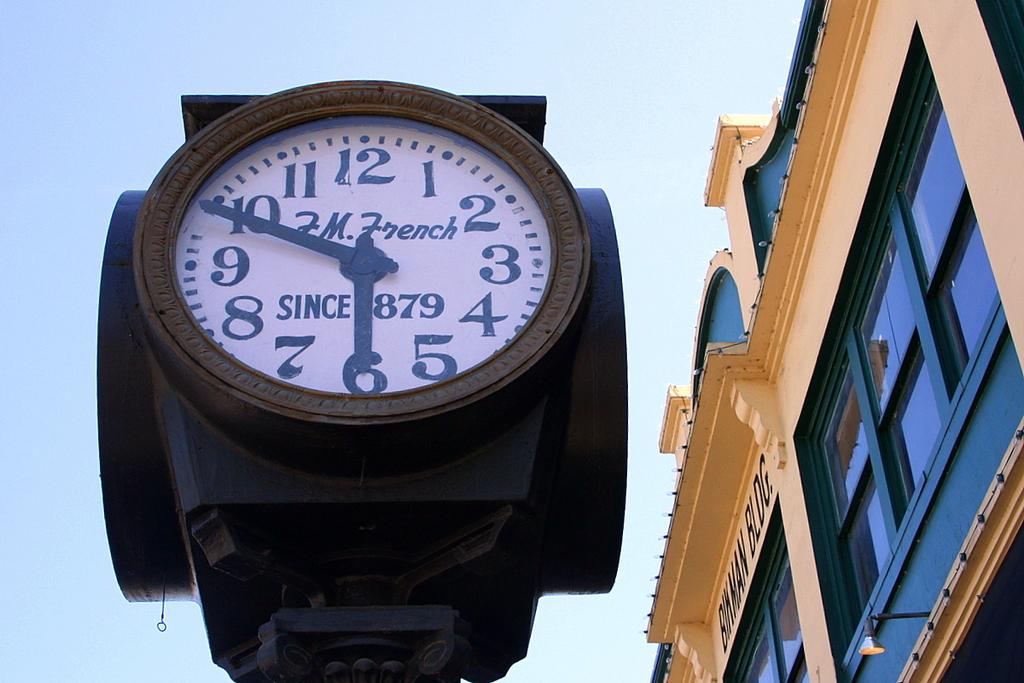What is the date that this clock says it has been around since?
Your answer should be compact. 1879. What time is displayed on the clock?
Provide a short and direct response. 6:50. 